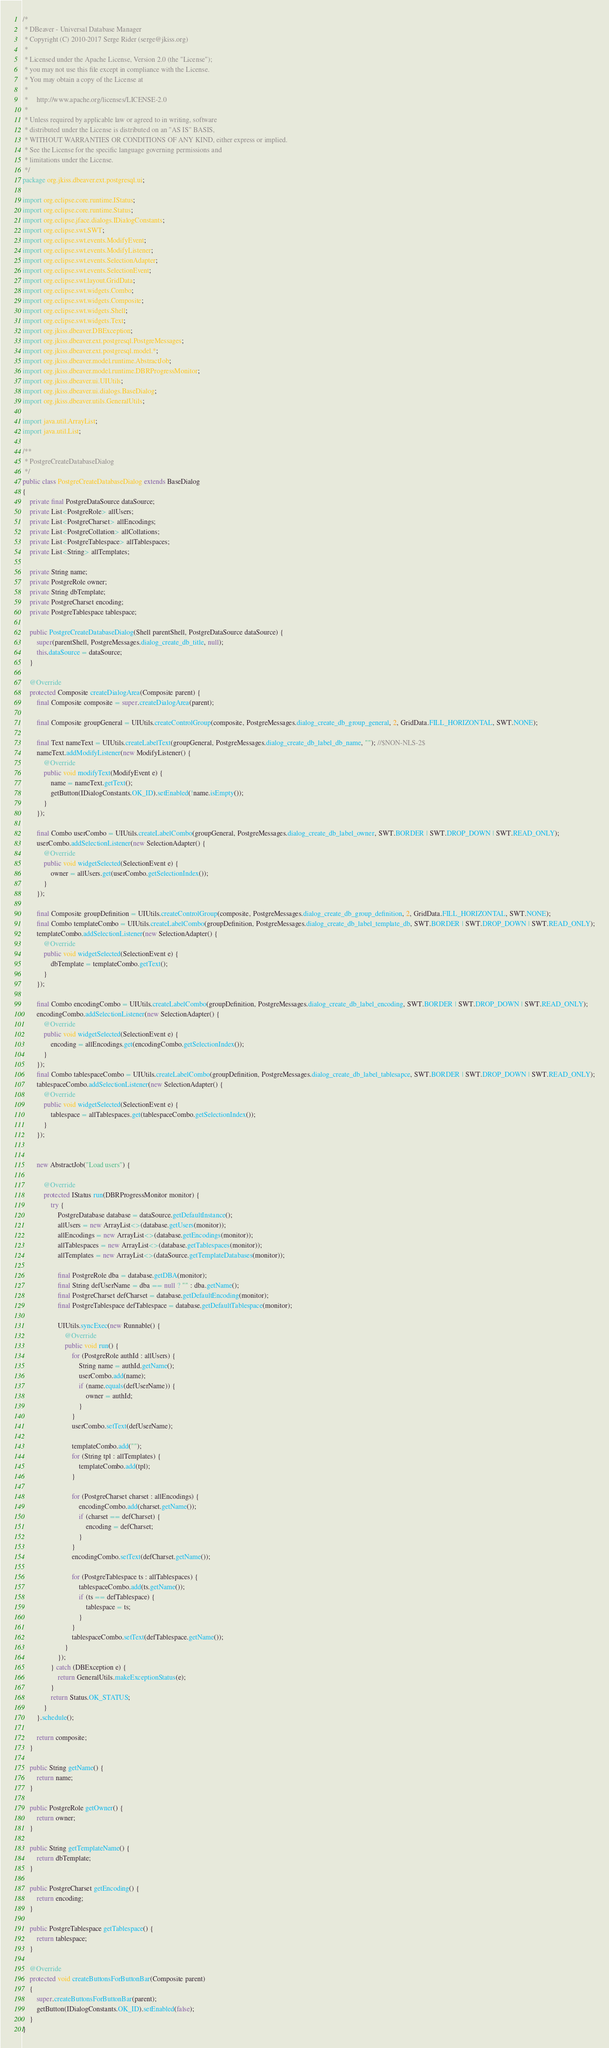<code> <loc_0><loc_0><loc_500><loc_500><_Java_>/*
 * DBeaver - Universal Database Manager
 * Copyright (C) 2010-2017 Serge Rider (serge@jkiss.org)
 *
 * Licensed under the Apache License, Version 2.0 (the "License");
 * you may not use this file except in compliance with the License.
 * You may obtain a copy of the License at
 *
 *     http://www.apache.org/licenses/LICENSE-2.0
 *
 * Unless required by applicable law or agreed to in writing, software
 * distributed under the License is distributed on an "AS IS" BASIS,
 * WITHOUT WARRANTIES OR CONDITIONS OF ANY KIND, either express or implied.
 * See the License for the specific language governing permissions and
 * limitations under the License.
 */
package org.jkiss.dbeaver.ext.postgresql.ui;

import org.eclipse.core.runtime.IStatus;
import org.eclipse.core.runtime.Status;
import org.eclipse.jface.dialogs.IDialogConstants;
import org.eclipse.swt.SWT;
import org.eclipse.swt.events.ModifyEvent;
import org.eclipse.swt.events.ModifyListener;
import org.eclipse.swt.events.SelectionAdapter;
import org.eclipse.swt.events.SelectionEvent;
import org.eclipse.swt.layout.GridData;
import org.eclipse.swt.widgets.Combo;
import org.eclipse.swt.widgets.Composite;
import org.eclipse.swt.widgets.Shell;
import org.eclipse.swt.widgets.Text;
import org.jkiss.dbeaver.DBException;
import org.jkiss.dbeaver.ext.postgresql.PostgreMessages;
import org.jkiss.dbeaver.ext.postgresql.model.*;
import org.jkiss.dbeaver.model.runtime.AbstractJob;
import org.jkiss.dbeaver.model.runtime.DBRProgressMonitor;
import org.jkiss.dbeaver.ui.UIUtils;
import org.jkiss.dbeaver.ui.dialogs.BaseDialog;
import org.jkiss.dbeaver.utils.GeneralUtils;

import java.util.ArrayList;
import java.util.List;

/**
 * PostgreCreateDatabaseDialog
 */
public class PostgreCreateDatabaseDialog extends BaseDialog
{
    private final PostgreDataSource dataSource;
    private List<PostgreRole> allUsers;
    private List<PostgreCharset> allEncodings;
    private List<PostgreCollation> allCollations;
    private List<PostgreTablespace> allTablespaces;
    private List<String> allTemplates;

    private String name;
    private PostgreRole owner;
    private String dbTemplate;
    private PostgreCharset encoding;
    private PostgreTablespace tablespace;

    public PostgreCreateDatabaseDialog(Shell parentShell, PostgreDataSource dataSource) {
        super(parentShell, PostgreMessages.dialog_create_db_title, null);
        this.dataSource = dataSource;
    }

    @Override
    protected Composite createDialogArea(Composite parent) {
        final Composite composite = super.createDialogArea(parent);

        final Composite groupGeneral = UIUtils.createControlGroup(composite, PostgreMessages.dialog_create_db_group_general, 2, GridData.FILL_HORIZONTAL, SWT.NONE);

        final Text nameText = UIUtils.createLabelText(groupGeneral, PostgreMessages.dialog_create_db_label_db_name, ""); //$NON-NLS-2$
        nameText.addModifyListener(new ModifyListener() {
            @Override
            public void modifyText(ModifyEvent e) {
                name = nameText.getText();
                getButton(IDialogConstants.OK_ID).setEnabled(!name.isEmpty());
            }
        });

        final Combo userCombo = UIUtils.createLabelCombo(groupGeneral, PostgreMessages.dialog_create_db_label_owner, SWT.BORDER | SWT.DROP_DOWN | SWT.READ_ONLY);
        userCombo.addSelectionListener(new SelectionAdapter() {
            @Override
            public void widgetSelected(SelectionEvent e) {
                owner = allUsers.get(userCombo.getSelectionIndex());
            }
        });

        final Composite groupDefinition = UIUtils.createControlGroup(composite, PostgreMessages.dialog_create_db_group_definition, 2, GridData.FILL_HORIZONTAL, SWT.NONE);
        final Combo templateCombo = UIUtils.createLabelCombo(groupDefinition, PostgreMessages.dialog_create_db_label_template_db, SWT.BORDER | SWT.DROP_DOWN | SWT.READ_ONLY);
        templateCombo.addSelectionListener(new SelectionAdapter() {
            @Override
            public void widgetSelected(SelectionEvent e) {
                dbTemplate = templateCombo.getText();
            }
        });

        final Combo encodingCombo = UIUtils.createLabelCombo(groupDefinition, PostgreMessages.dialog_create_db_label_encoding, SWT.BORDER | SWT.DROP_DOWN | SWT.READ_ONLY);
        encodingCombo.addSelectionListener(new SelectionAdapter() {
            @Override
            public void widgetSelected(SelectionEvent e) {
                encoding = allEncodings.get(encodingCombo.getSelectionIndex());
            }
        });
        final Combo tablespaceCombo = UIUtils.createLabelCombo(groupDefinition, PostgreMessages.dialog_create_db_label_tablesapce, SWT.BORDER | SWT.DROP_DOWN | SWT.READ_ONLY);
        tablespaceCombo.addSelectionListener(new SelectionAdapter() {
            @Override
            public void widgetSelected(SelectionEvent e) {
                tablespace = allTablespaces.get(tablespaceCombo.getSelectionIndex());
            }
        });


        new AbstractJob("Load users") {

            @Override
            protected IStatus run(DBRProgressMonitor monitor) {
                try {
                    PostgreDatabase database = dataSource.getDefaultInstance();
                    allUsers = new ArrayList<>(database.getUsers(monitor));
                    allEncodings = new ArrayList<>(database.getEncodings(monitor));
                    allTablespaces = new ArrayList<>(database.getTablespaces(monitor));
                    allTemplates = new ArrayList<>(dataSource.getTemplateDatabases(monitor));

                    final PostgreRole dba = database.getDBA(monitor);
                    final String defUserName = dba == null ? "" : dba.getName();
                    final PostgreCharset defCharset = database.getDefaultEncoding(monitor);
                    final PostgreTablespace defTablespace = database.getDefaultTablespace(monitor);

                    UIUtils.syncExec(new Runnable() {
                        @Override
                        public void run() {
                            for (PostgreRole authId : allUsers) {
                                String name = authId.getName();
                                userCombo.add(name);
                                if (name.equals(defUserName)) {
                                    owner = authId;
                                }
                            }
                            userCombo.setText(defUserName);

                            templateCombo.add("");
                            for (String tpl : allTemplates) {
                                templateCombo.add(tpl);
                            }

                            for (PostgreCharset charset : allEncodings) {
                                encodingCombo.add(charset.getName());
                                if (charset == defCharset) {
                                    encoding = defCharset;
                                }
                            }
                            encodingCombo.setText(defCharset.getName());

                            for (PostgreTablespace ts : allTablespaces) {
                                tablespaceCombo.add(ts.getName());
                                if (ts == defTablespace) {
                                    tablespace = ts;
                                }
                            }
                            tablespaceCombo.setText(defTablespace.getName());
                        }
                    });
                } catch (DBException e) {
                    return GeneralUtils.makeExceptionStatus(e);
                }
                return Status.OK_STATUS;
            }
        }.schedule();

        return composite;
    }

    public String getName() {
        return name;
    }

    public PostgreRole getOwner() {
        return owner;
    }

    public String getTemplateName() {
        return dbTemplate;
    }

    public PostgreCharset getEncoding() {
        return encoding;
    }

    public PostgreTablespace getTablespace() {
        return tablespace;
    }

    @Override
    protected void createButtonsForButtonBar(Composite parent)
    {
        super.createButtonsForButtonBar(parent);
        getButton(IDialogConstants.OK_ID).setEnabled(false);
    }
}
</code> 